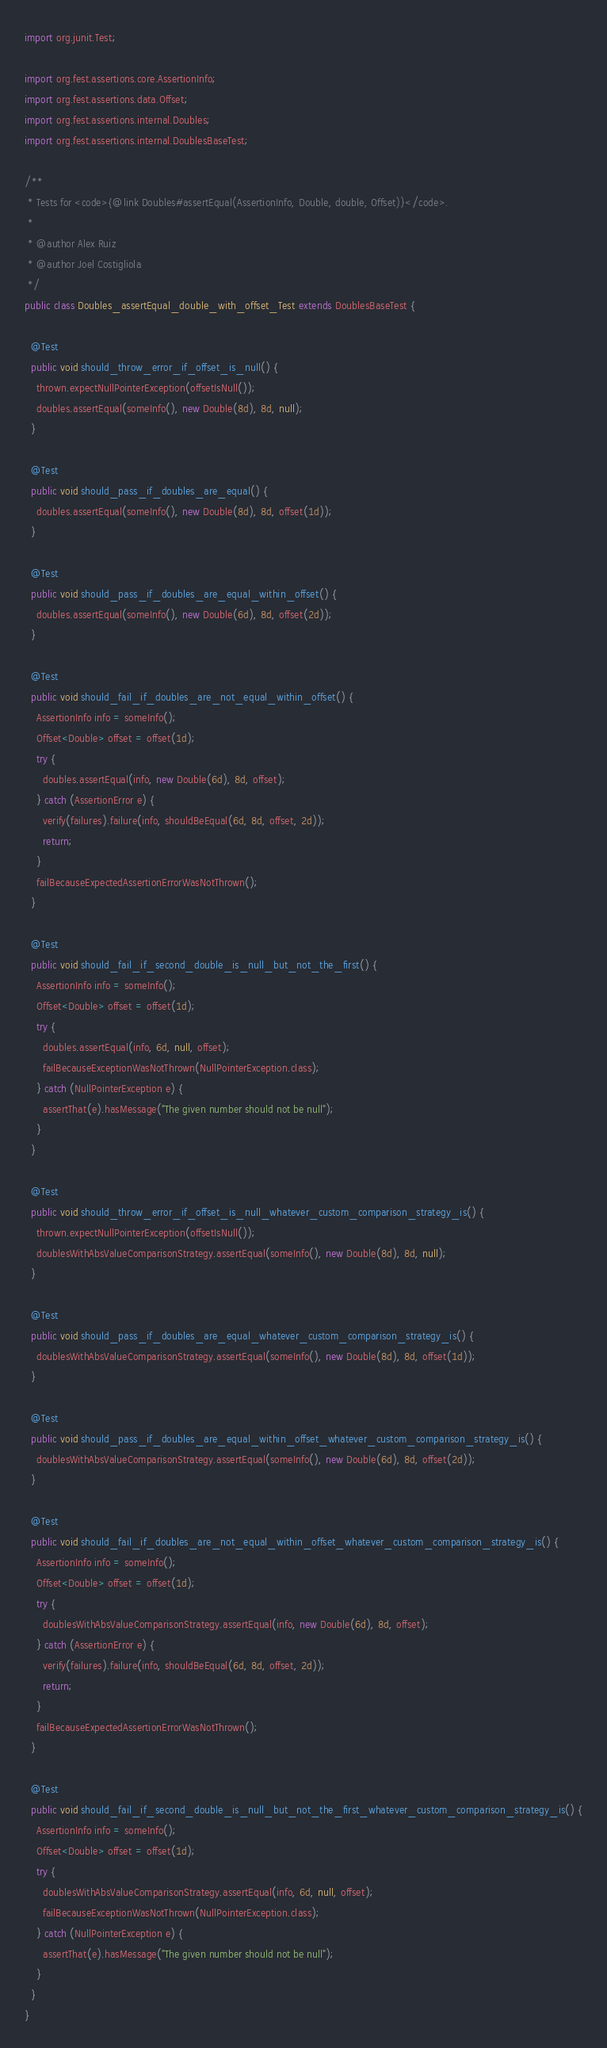Convert code to text. <code><loc_0><loc_0><loc_500><loc_500><_Java_>import org.junit.Test;

import org.fest.assertions.core.AssertionInfo;
import org.fest.assertions.data.Offset;
import org.fest.assertions.internal.Doubles;
import org.fest.assertions.internal.DoublesBaseTest;

/**
 * Tests for <code>{@link Doubles#assertEqual(AssertionInfo, Double, double, Offset)}</code>.
 * 
 * @author Alex Ruiz
 * @author Joel Costigliola
 */
public class Doubles_assertEqual_double_with_offset_Test extends DoublesBaseTest {

  @Test
  public void should_throw_error_if_offset_is_null() {
    thrown.expectNullPointerException(offsetIsNull());
    doubles.assertEqual(someInfo(), new Double(8d), 8d, null);
  }

  @Test
  public void should_pass_if_doubles_are_equal() {
    doubles.assertEqual(someInfo(), new Double(8d), 8d, offset(1d));
  }

  @Test
  public void should_pass_if_doubles_are_equal_within_offset() {
    doubles.assertEqual(someInfo(), new Double(6d), 8d, offset(2d));
  }

  @Test
  public void should_fail_if_doubles_are_not_equal_within_offset() {
    AssertionInfo info = someInfo();
    Offset<Double> offset = offset(1d);
    try {
      doubles.assertEqual(info, new Double(6d), 8d, offset);
    } catch (AssertionError e) {
      verify(failures).failure(info, shouldBeEqual(6d, 8d, offset, 2d));
      return;
    }
    failBecauseExpectedAssertionErrorWasNotThrown();
  }

  @Test
  public void should_fail_if_second_double_is_null_but_not_the_first() {
    AssertionInfo info = someInfo();
    Offset<Double> offset = offset(1d);
    try {
      doubles.assertEqual(info, 6d, null, offset);
      failBecauseExceptionWasNotThrown(NullPointerException.class);
    } catch (NullPointerException e) {
      assertThat(e).hasMessage("The given number should not be null");
    }
  }

  @Test
  public void should_throw_error_if_offset_is_null_whatever_custom_comparison_strategy_is() {
    thrown.expectNullPointerException(offsetIsNull());
    doublesWithAbsValueComparisonStrategy.assertEqual(someInfo(), new Double(8d), 8d, null);
  }

  @Test
  public void should_pass_if_doubles_are_equal_whatever_custom_comparison_strategy_is() {
    doublesWithAbsValueComparisonStrategy.assertEqual(someInfo(), new Double(8d), 8d, offset(1d));
  }

  @Test
  public void should_pass_if_doubles_are_equal_within_offset_whatever_custom_comparison_strategy_is() {
    doublesWithAbsValueComparisonStrategy.assertEqual(someInfo(), new Double(6d), 8d, offset(2d));
  }

  @Test
  public void should_fail_if_doubles_are_not_equal_within_offset_whatever_custom_comparison_strategy_is() {
    AssertionInfo info = someInfo();
    Offset<Double> offset = offset(1d);
    try {
      doublesWithAbsValueComparisonStrategy.assertEqual(info, new Double(6d), 8d, offset);
    } catch (AssertionError e) {
      verify(failures).failure(info, shouldBeEqual(6d, 8d, offset, 2d));
      return;
    }
    failBecauseExpectedAssertionErrorWasNotThrown();
  }

  @Test
  public void should_fail_if_second_double_is_null_but_not_the_first_whatever_custom_comparison_strategy_is() {
    AssertionInfo info = someInfo();
    Offset<Double> offset = offset(1d);
    try {
      doublesWithAbsValueComparisonStrategy.assertEqual(info, 6d, null, offset);
      failBecauseExceptionWasNotThrown(NullPointerException.class);
    } catch (NullPointerException e) {
      assertThat(e).hasMessage("The given number should not be null");
    }
  }
}
</code> 